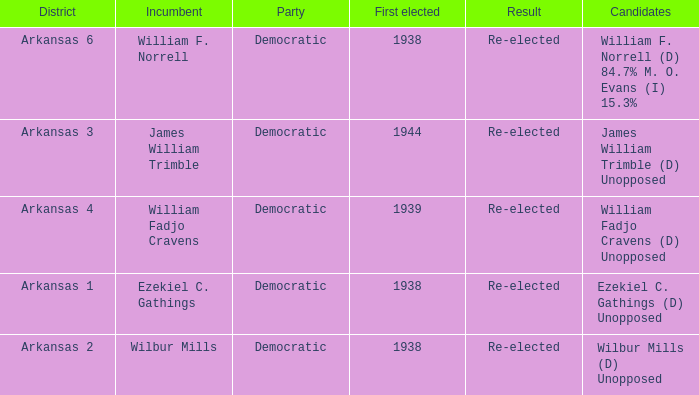How many incumbents had a district of Arkansas 3? 1.0. 